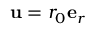Convert formula to latex. <formula><loc_0><loc_0><loc_500><loc_500>u = r _ { 0 } e _ { r }</formula> 